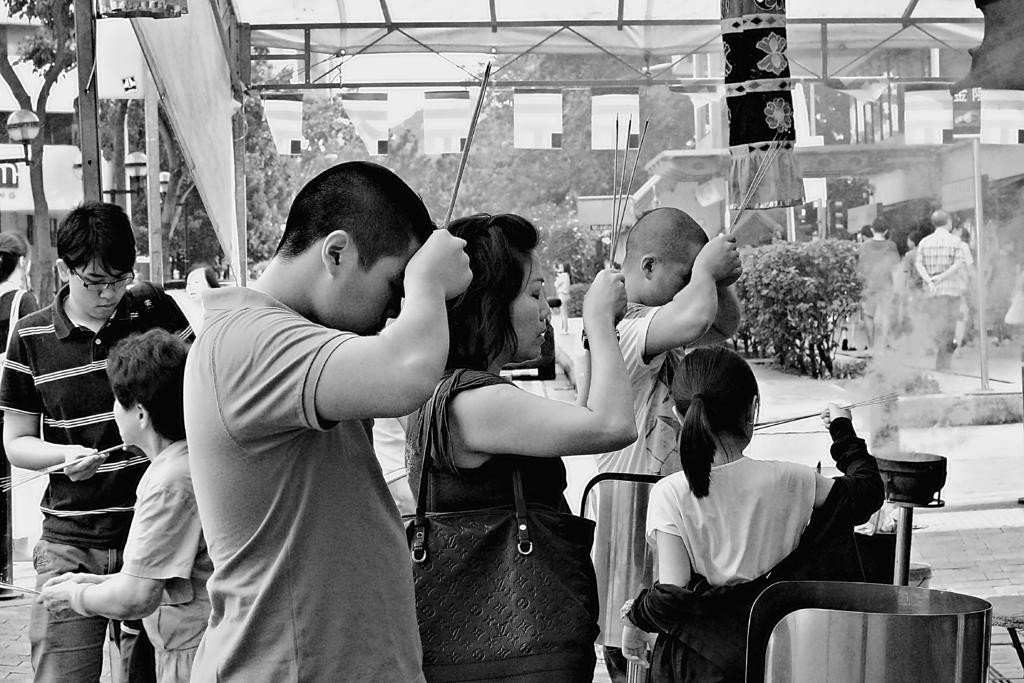What is happening in the image involving the group of people? The people in the image are holding incense sticks in their hands. What can be seen in the background of the image? There are trees in the background of the image. What type of whip is being used by the people in the image? There is no whip present in the image; the people are holding incense sticks. 